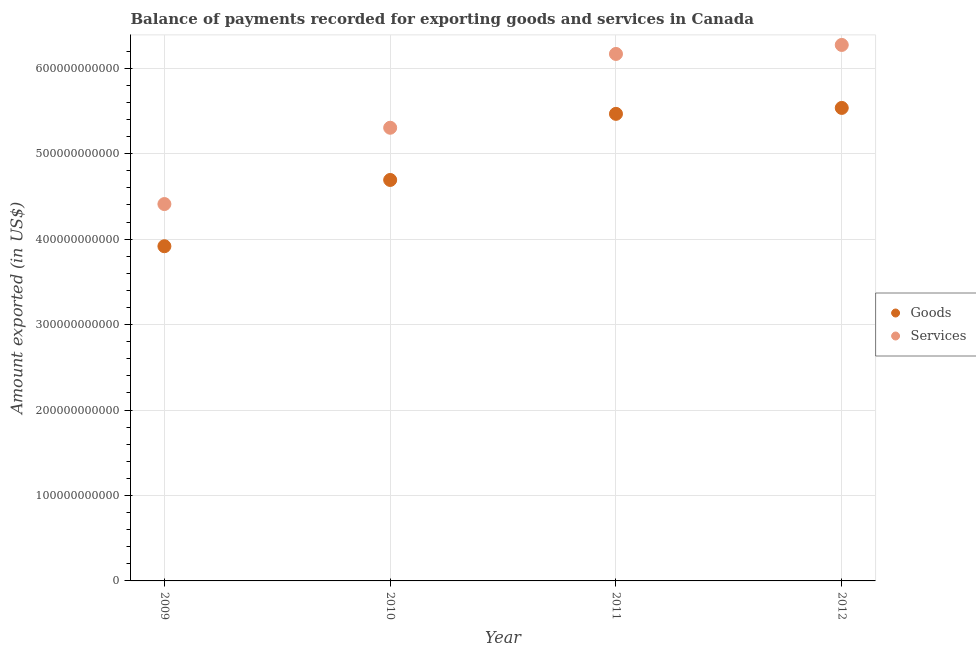How many different coloured dotlines are there?
Keep it short and to the point. 2. Is the number of dotlines equal to the number of legend labels?
Your response must be concise. Yes. What is the amount of goods exported in 2012?
Your response must be concise. 5.54e+11. Across all years, what is the maximum amount of goods exported?
Provide a succinct answer. 5.54e+11. Across all years, what is the minimum amount of services exported?
Offer a very short reply. 4.41e+11. In which year was the amount of goods exported maximum?
Ensure brevity in your answer.  2012. In which year was the amount of goods exported minimum?
Make the answer very short. 2009. What is the total amount of services exported in the graph?
Make the answer very short. 2.22e+12. What is the difference between the amount of services exported in 2009 and that in 2012?
Provide a short and direct response. -1.86e+11. What is the difference between the amount of goods exported in 2011 and the amount of services exported in 2010?
Your answer should be very brief. 1.63e+1. What is the average amount of goods exported per year?
Give a very brief answer. 4.90e+11. In the year 2009, what is the difference between the amount of services exported and amount of goods exported?
Provide a short and direct response. 4.94e+1. In how many years, is the amount of goods exported greater than 540000000000 US$?
Ensure brevity in your answer.  2. What is the ratio of the amount of goods exported in 2009 to that in 2010?
Your response must be concise. 0.83. Is the difference between the amount of services exported in 2010 and 2012 greater than the difference between the amount of goods exported in 2010 and 2012?
Ensure brevity in your answer.  No. What is the difference between the highest and the second highest amount of services exported?
Keep it short and to the point. 1.05e+1. What is the difference between the highest and the lowest amount of goods exported?
Your answer should be very brief. 1.62e+11. In how many years, is the amount of services exported greater than the average amount of services exported taken over all years?
Offer a very short reply. 2. Is the sum of the amount of services exported in 2010 and 2012 greater than the maximum amount of goods exported across all years?
Give a very brief answer. Yes. Is the amount of services exported strictly less than the amount of goods exported over the years?
Offer a terse response. No. What is the difference between two consecutive major ticks on the Y-axis?
Make the answer very short. 1.00e+11. Does the graph contain any zero values?
Offer a very short reply. No. Does the graph contain grids?
Keep it short and to the point. Yes. Where does the legend appear in the graph?
Offer a terse response. Center right. How many legend labels are there?
Your answer should be very brief. 2. How are the legend labels stacked?
Provide a succinct answer. Vertical. What is the title of the graph?
Provide a short and direct response. Balance of payments recorded for exporting goods and services in Canada. Does "Young" appear as one of the legend labels in the graph?
Your answer should be compact. No. What is the label or title of the Y-axis?
Your answer should be very brief. Amount exported (in US$). What is the Amount exported (in US$) of Goods in 2009?
Your answer should be very brief. 3.92e+11. What is the Amount exported (in US$) of Services in 2009?
Provide a succinct answer. 4.41e+11. What is the Amount exported (in US$) of Goods in 2010?
Your response must be concise. 4.69e+11. What is the Amount exported (in US$) in Services in 2010?
Keep it short and to the point. 5.30e+11. What is the Amount exported (in US$) in Goods in 2011?
Offer a very short reply. 5.47e+11. What is the Amount exported (in US$) in Services in 2011?
Give a very brief answer. 6.17e+11. What is the Amount exported (in US$) of Goods in 2012?
Provide a short and direct response. 5.54e+11. What is the Amount exported (in US$) in Services in 2012?
Offer a terse response. 6.27e+11. Across all years, what is the maximum Amount exported (in US$) in Goods?
Your answer should be very brief. 5.54e+11. Across all years, what is the maximum Amount exported (in US$) in Services?
Offer a very short reply. 6.27e+11. Across all years, what is the minimum Amount exported (in US$) in Goods?
Offer a very short reply. 3.92e+11. Across all years, what is the minimum Amount exported (in US$) in Services?
Offer a terse response. 4.41e+11. What is the total Amount exported (in US$) of Goods in the graph?
Ensure brevity in your answer.  1.96e+12. What is the total Amount exported (in US$) in Services in the graph?
Keep it short and to the point. 2.22e+12. What is the difference between the Amount exported (in US$) of Goods in 2009 and that in 2010?
Provide a short and direct response. -7.76e+1. What is the difference between the Amount exported (in US$) of Services in 2009 and that in 2010?
Provide a short and direct response. -8.93e+1. What is the difference between the Amount exported (in US$) of Goods in 2009 and that in 2011?
Give a very brief answer. -1.55e+11. What is the difference between the Amount exported (in US$) of Services in 2009 and that in 2011?
Make the answer very short. -1.76e+11. What is the difference between the Amount exported (in US$) of Goods in 2009 and that in 2012?
Your response must be concise. -1.62e+11. What is the difference between the Amount exported (in US$) in Services in 2009 and that in 2012?
Make the answer very short. -1.86e+11. What is the difference between the Amount exported (in US$) in Goods in 2010 and that in 2011?
Offer a very short reply. -7.74e+1. What is the difference between the Amount exported (in US$) in Services in 2010 and that in 2011?
Your answer should be very brief. -8.64e+1. What is the difference between the Amount exported (in US$) of Goods in 2010 and that in 2012?
Offer a very short reply. -8.43e+1. What is the difference between the Amount exported (in US$) in Services in 2010 and that in 2012?
Make the answer very short. -9.69e+1. What is the difference between the Amount exported (in US$) of Goods in 2011 and that in 2012?
Your response must be concise. -6.95e+09. What is the difference between the Amount exported (in US$) in Services in 2011 and that in 2012?
Provide a succinct answer. -1.05e+1. What is the difference between the Amount exported (in US$) in Goods in 2009 and the Amount exported (in US$) in Services in 2010?
Offer a very short reply. -1.39e+11. What is the difference between the Amount exported (in US$) in Goods in 2009 and the Amount exported (in US$) in Services in 2011?
Make the answer very short. -2.25e+11. What is the difference between the Amount exported (in US$) in Goods in 2009 and the Amount exported (in US$) in Services in 2012?
Your answer should be very brief. -2.36e+11. What is the difference between the Amount exported (in US$) in Goods in 2010 and the Amount exported (in US$) in Services in 2011?
Ensure brevity in your answer.  -1.47e+11. What is the difference between the Amount exported (in US$) of Goods in 2010 and the Amount exported (in US$) of Services in 2012?
Your answer should be very brief. -1.58e+11. What is the difference between the Amount exported (in US$) in Goods in 2011 and the Amount exported (in US$) in Services in 2012?
Provide a succinct answer. -8.07e+1. What is the average Amount exported (in US$) of Goods per year?
Your answer should be very brief. 4.90e+11. What is the average Amount exported (in US$) of Services per year?
Offer a terse response. 5.54e+11. In the year 2009, what is the difference between the Amount exported (in US$) in Goods and Amount exported (in US$) in Services?
Provide a succinct answer. -4.94e+1. In the year 2010, what is the difference between the Amount exported (in US$) in Goods and Amount exported (in US$) in Services?
Provide a succinct answer. -6.11e+1. In the year 2011, what is the difference between the Amount exported (in US$) in Goods and Amount exported (in US$) in Services?
Provide a short and direct response. -7.01e+1. In the year 2012, what is the difference between the Amount exported (in US$) of Goods and Amount exported (in US$) of Services?
Ensure brevity in your answer.  -7.37e+1. What is the ratio of the Amount exported (in US$) of Goods in 2009 to that in 2010?
Your answer should be compact. 0.83. What is the ratio of the Amount exported (in US$) of Services in 2009 to that in 2010?
Provide a succinct answer. 0.83. What is the ratio of the Amount exported (in US$) of Goods in 2009 to that in 2011?
Offer a very short reply. 0.72. What is the ratio of the Amount exported (in US$) of Services in 2009 to that in 2011?
Provide a succinct answer. 0.72. What is the ratio of the Amount exported (in US$) of Goods in 2009 to that in 2012?
Your answer should be compact. 0.71. What is the ratio of the Amount exported (in US$) in Services in 2009 to that in 2012?
Provide a succinct answer. 0.7. What is the ratio of the Amount exported (in US$) in Goods in 2010 to that in 2011?
Give a very brief answer. 0.86. What is the ratio of the Amount exported (in US$) of Services in 2010 to that in 2011?
Ensure brevity in your answer.  0.86. What is the ratio of the Amount exported (in US$) in Goods in 2010 to that in 2012?
Make the answer very short. 0.85. What is the ratio of the Amount exported (in US$) of Services in 2010 to that in 2012?
Your response must be concise. 0.85. What is the ratio of the Amount exported (in US$) of Goods in 2011 to that in 2012?
Provide a short and direct response. 0.99. What is the ratio of the Amount exported (in US$) in Services in 2011 to that in 2012?
Ensure brevity in your answer.  0.98. What is the difference between the highest and the second highest Amount exported (in US$) in Goods?
Your answer should be compact. 6.95e+09. What is the difference between the highest and the second highest Amount exported (in US$) of Services?
Offer a very short reply. 1.05e+1. What is the difference between the highest and the lowest Amount exported (in US$) of Goods?
Your answer should be very brief. 1.62e+11. What is the difference between the highest and the lowest Amount exported (in US$) in Services?
Make the answer very short. 1.86e+11. 